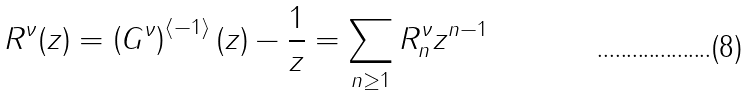Convert formula to latex. <formula><loc_0><loc_0><loc_500><loc_500>R ^ { \nu } ( z ) = \left ( G ^ { \nu } \right ) ^ { \langle - 1 \rangle } ( z ) - \frac { 1 } { z } = \sum _ { n \geq 1 } R ^ { \nu } _ { n } z ^ { n - 1 }</formula> 